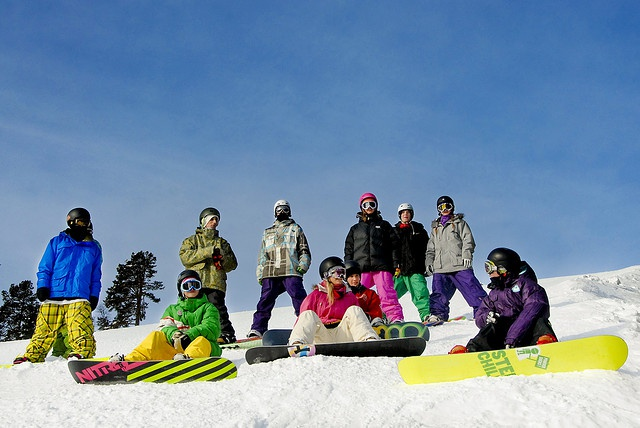Describe the objects in this image and their specific colors. I can see people in blue, darkblue, black, and olive tones, snowboard in blue, khaki, yellow, ivory, and lightgreen tones, people in blue, black, purple, and navy tones, people in blue, darkgreen, black, and olive tones, and people in blue, darkgray, beige, black, and brown tones in this image. 